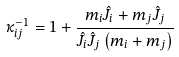Convert formula to latex. <formula><loc_0><loc_0><loc_500><loc_500>\kappa _ { i j } ^ { - 1 } = 1 + \frac { m _ { i } \hat { J } _ { i } + m _ { j } \hat { J } _ { j } } { \hat { J } _ { i } \hat { J } _ { j } \left ( m _ { i } + m _ { j } \right ) }</formula> 